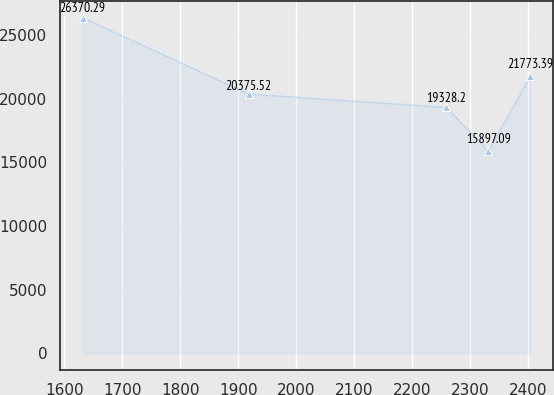Convert chart. <chart><loc_0><loc_0><loc_500><loc_500><line_chart><ecel><fcel>Unnamed: 1<nl><fcel>1631.54<fcel>26370.3<nl><fcel>1918.13<fcel>20375.5<nl><fcel>2259.68<fcel>19328.2<nl><fcel>2332.1<fcel>15897.1<nl><fcel>2404.52<fcel>21773.4<nl></chart> 